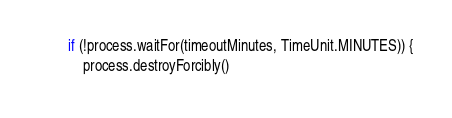<code> <loc_0><loc_0><loc_500><loc_500><_Kotlin_>        if (!process.waitFor(timeoutMinutes, TimeUnit.MINUTES)) {
            process.destroyForcibly()</code> 